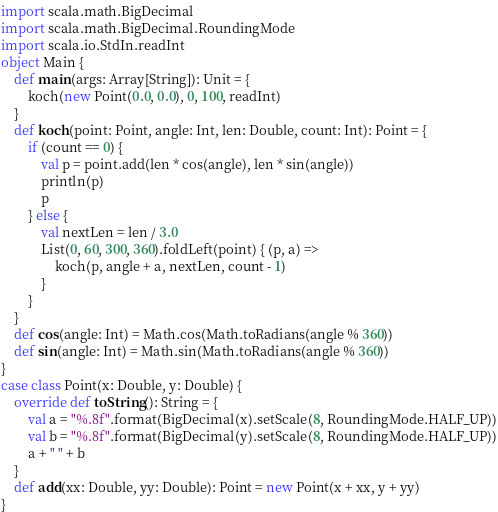<code> <loc_0><loc_0><loc_500><loc_500><_Scala_>import scala.math.BigDecimal
import scala.math.BigDecimal.RoundingMode
import scala.io.StdIn.readInt
object Main {
    def main(args: Array[String]): Unit = {
        koch(new Point(0.0, 0.0), 0, 100, readInt)
    }
    def koch(point: Point, angle: Int, len: Double, count: Int): Point = {
        if (count == 0) {
            val p = point.add(len * cos(angle), len * sin(angle))
            println(p)
            p
        } else {
            val nextLen = len / 3.0
            List(0, 60, 300, 360).foldLeft(point) { (p, a) =>
                koch(p, angle + a, nextLen, count - 1)
            }
        }
    }
    def cos(angle: Int) = Math.cos(Math.toRadians(angle % 360))
    def sin(angle: Int) = Math.sin(Math.toRadians(angle % 360))
}
case class Point(x: Double, y: Double) {
    override def toString(): String = {
        val a = "%.8f".format(BigDecimal(x).setScale(8, RoundingMode.HALF_UP))
        val b = "%.8f".format(BigDecimal(y).setScale(8, RoundingMode.HALF_UP))
        a + " " + b
    }
    def add(xx: Double, yy: Double): Point = new Point(x + xx, y + yy)
}
</code> 